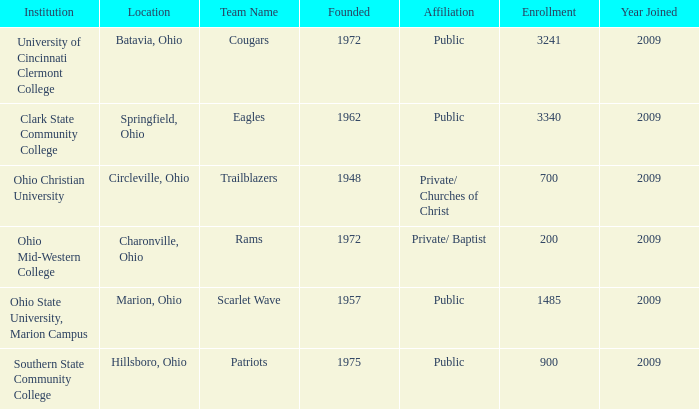What is the location for the team name of eagles? Springfield, Ohio. 